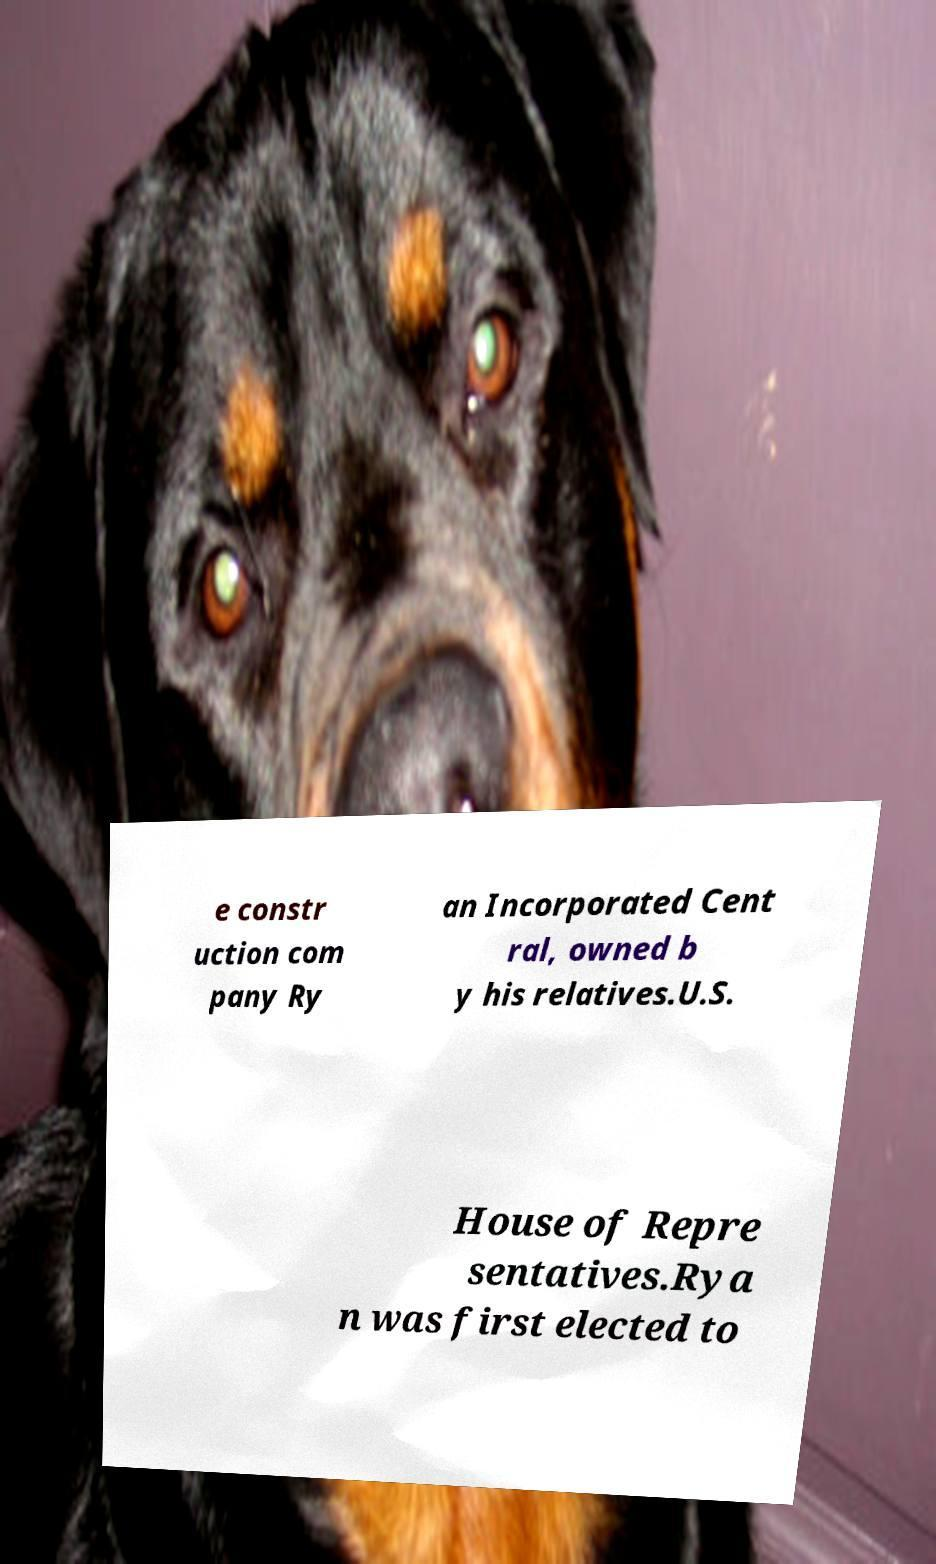What messages or text are displayed in this image? I need them in a readable, typed format. e constr uction com pany Ry an Incorporated Cent ral, owned b y his relatives.U.S. House of Repre sentatives.Rya n was first elected to 